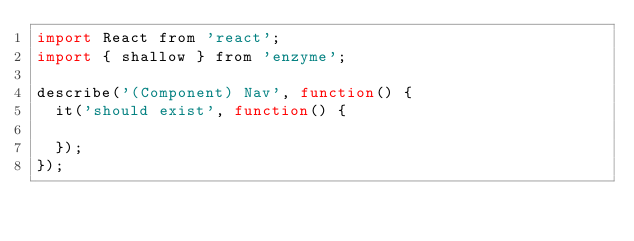Convert code to text. <code><loc_0><loc_0><loc_500><loc_500><_JavaScript_>import React from 'react';
import { shallow } from 'enzyme';

describe('(Component) Nav', function() {
  it('should exist', function() {

  });
});
</code> 